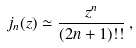Convert formula to latex. <formula><loc_0><loc_0><loc_500><loc_500>j _ { n } ( z ) \simeq \frac { z ^ { n } } { ( 2 n + 1 ) ! ! } \, ,</formula> 